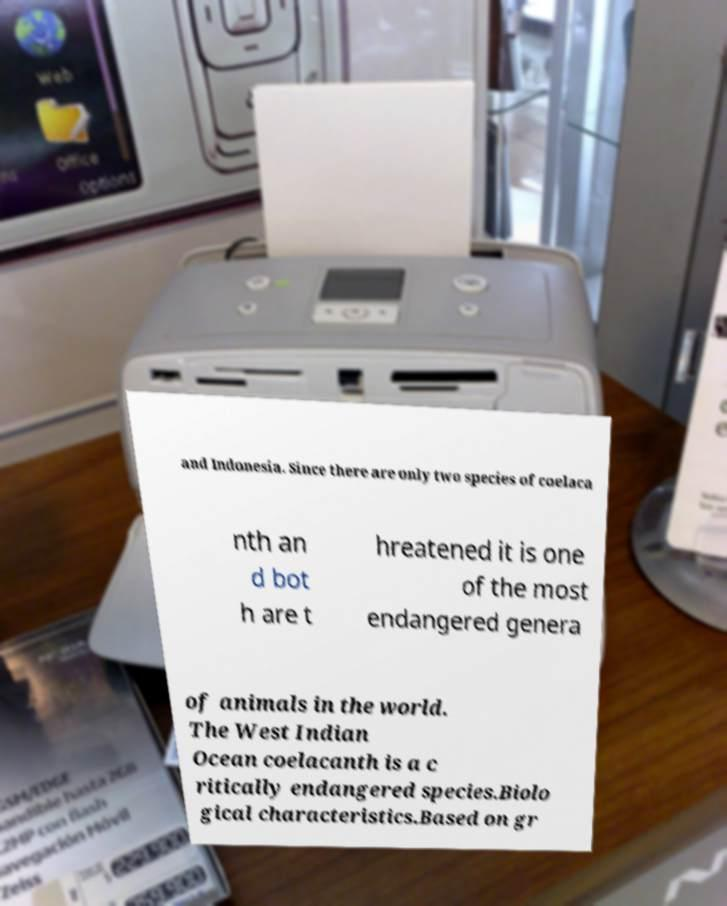Could you extract and type out the text from this image? and Indonesia. Since there are only two species of coelaca nth an d bot h are t hreatened it is one of the most endangered genera of animals in the world. The West Indian Ocean coelacanth is a c ritically endangered species.Biolo gical characteristics.Based on gr 